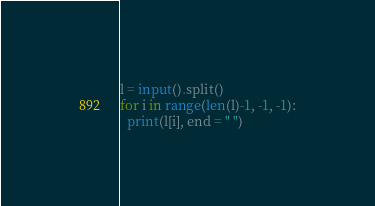Convert code to text. <code><loc_0><loc_0><loc_500><loc_500><_Python_>l = input().split()
for i in range(len(l)-1, -1, -1):
  print(l[i], end = " ")</code> 